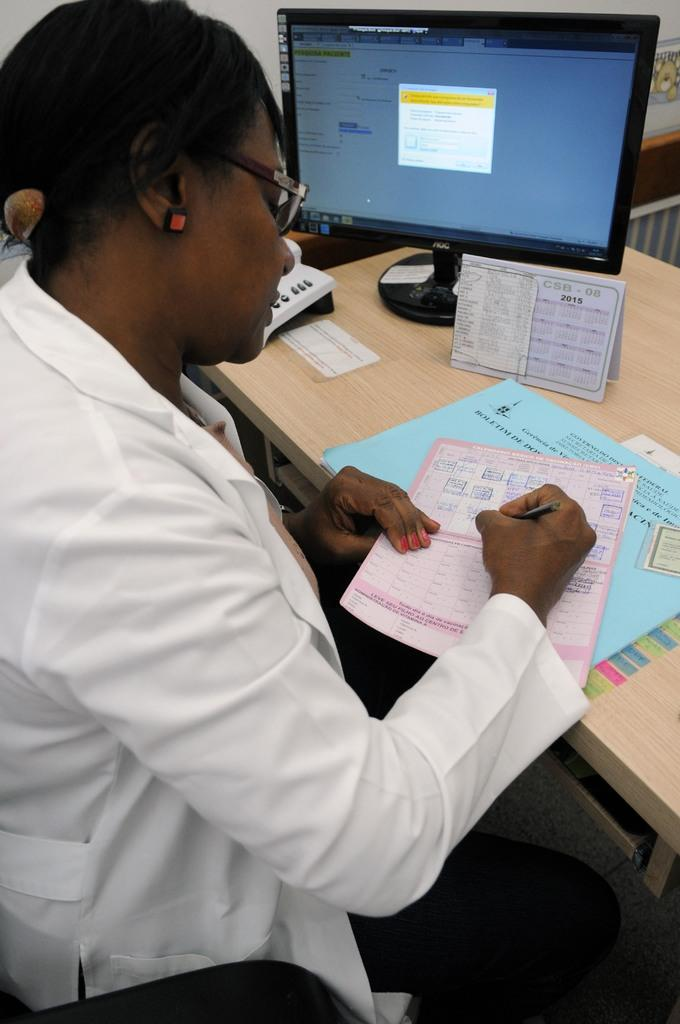<image>
Render a clear and concise summary of the photo. A person sits at a computer and looks at a calendar from 2015. 